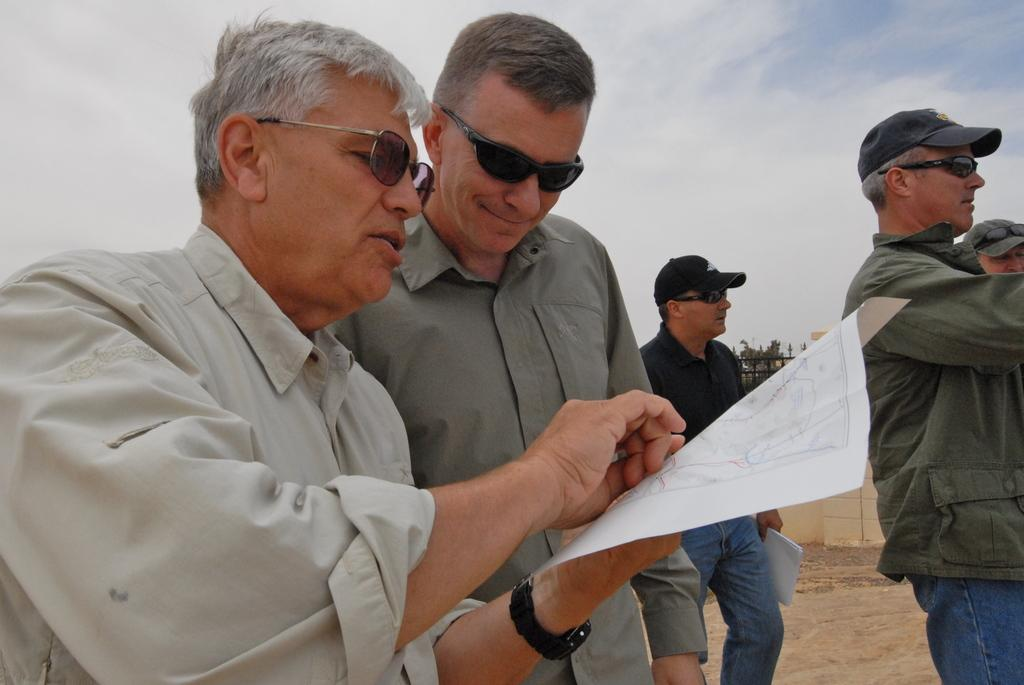What is happening in the image? There are people standing in the image. Can you describe the clothing of the people? The people are wearing different color dresses. What are some of the people holding? Some people are holding papers. What can be seen in the background of the image? The sky is visible in the image. What is the color of the sky in the image? The sky has a white and blue color. What is the smell of the tiger in the image? There is no tiger present in the image, so there is no smell to describe. 